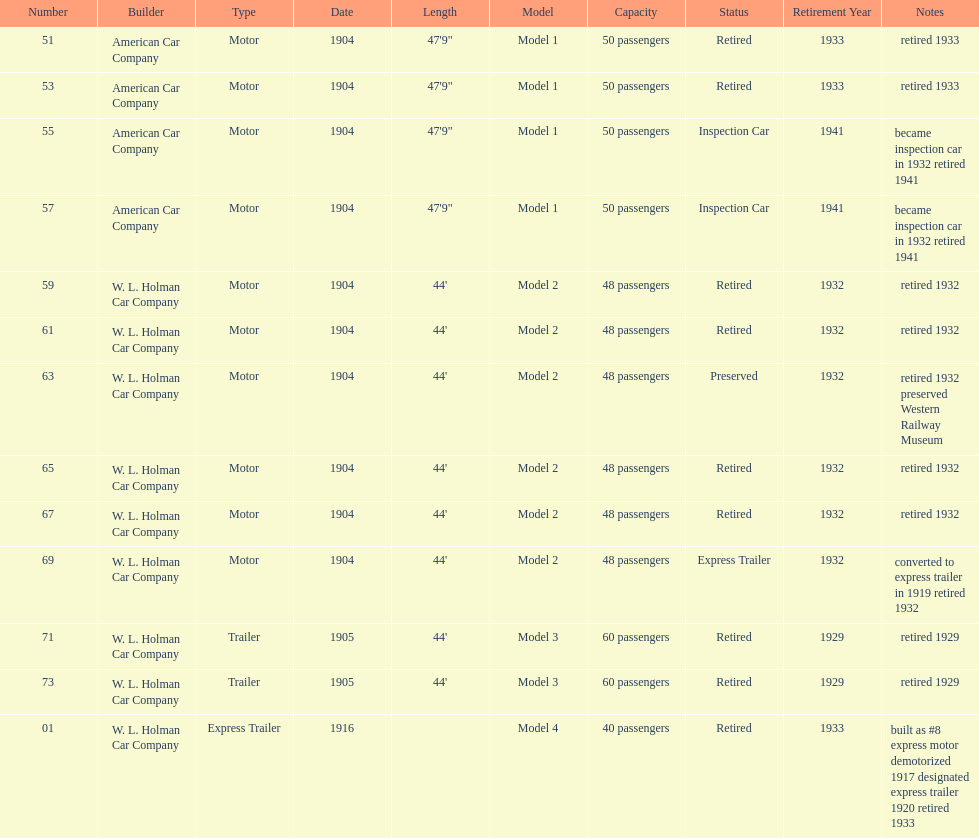How long did it take number 71 to retire? 24. 